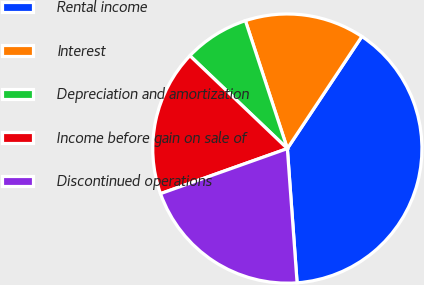Convert chart to OTSL. <chart><loc_0><loc_0><loc_500><loc_500><pie_chart><fcel>Rental income<fcel>Interest<fcel>Depreciation and amortization<fcel>Income before gain on sale of<fcel>Discontinued operations<nl><fcel>39.51%<fcel>14.38%<fcel>7.84%<fcel>17.55%<fcel>20.72%<nl></chart> 